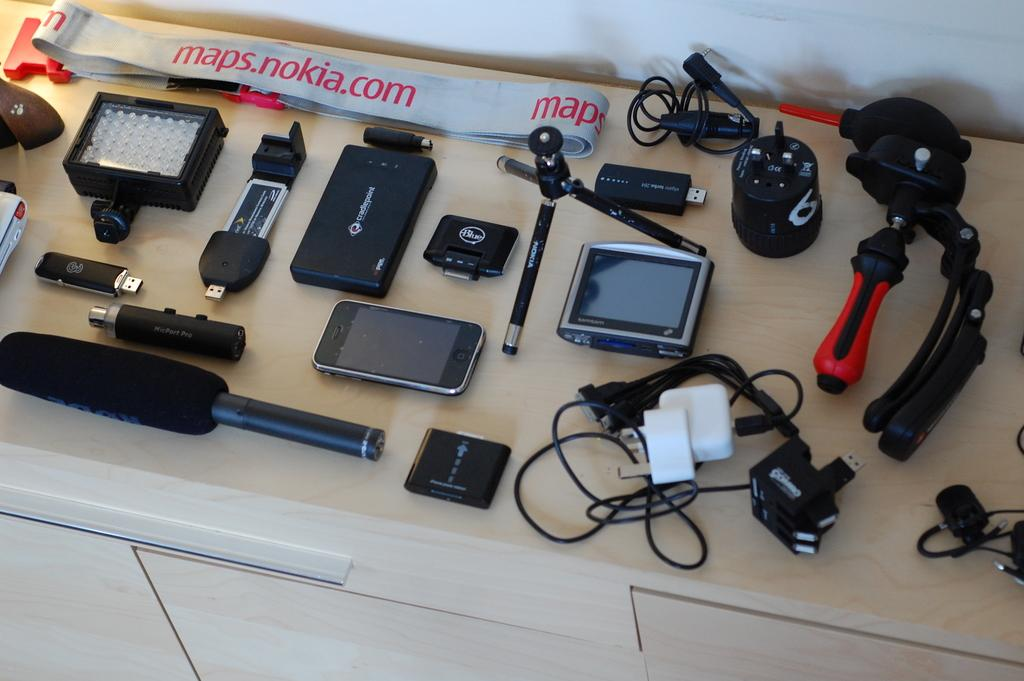<image>
Describe the image concisely. A bunch of camera equipment on a table with a strap that says maps.nokia.com. 